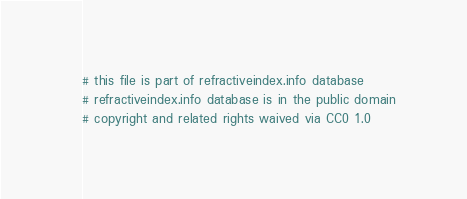Convert code to text. <code><loc_0><loc_0><loc_500><loc_500><_YAML_># this file is part of refractiveindex.info database
# refractiveindex.info database is in the public domain
# copyright and related rights waived via CC0 1.0
</code> 